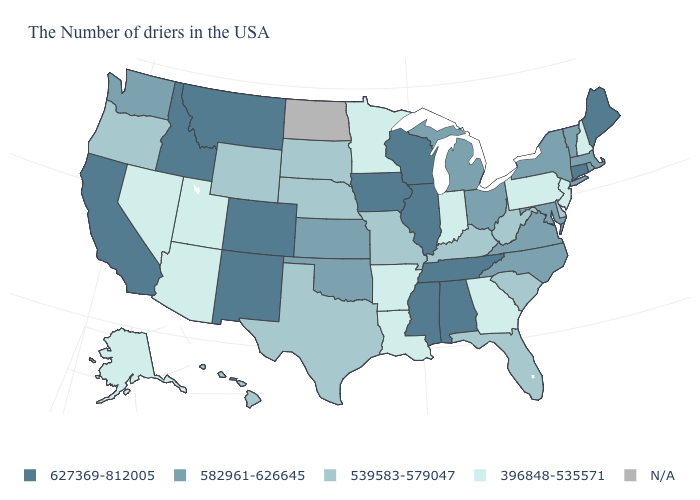What is the value of Washington?
Quick response, please. 582961-626645. What is the value of Mississippi?
Be succinct. 627369-812005. Which states hav the highest value in the MidWest?
Keep it brief. Wisconsin, Illinois, Iowa. What is the value of North Carolina?
Concise answer only. 582961-626645. What is the value of Oklahoma?
Answer briefly. 582961-626645. Is the legend a continuous bar?
Give a very brief answer. No. What is the lowest value in the USA?
Answer briefly. 396848-535571. How many symbols are there in the legend?
Answer briefly. 5. How many symbols are there in the legend?
Keep it brief. 5. What is the value of West Virginia?
Concise answer only. 539583-579047. Does Louisiana have the lowest value in the South?
Answer briefly. Yes. Name the states that have a value in the range 539583-579047?
Be succinct. Delaware, South Carolina, West Virginia, Florida, Kentucky, Missouri, Nebraska, Texas, South Dakota, Wyoming, Oregon, Hawaii. Name the states that have a value in the range 627369-812005?
Short answer required. Maine, Connecticut, Alabama, Tennessee, Wisconsin, Illinois, Mississippi, Iowa, Colorado, New Mexico, Montana, Idaho, California. What is the highest value in the USA?
Write a very short answer. 627369-812005. 